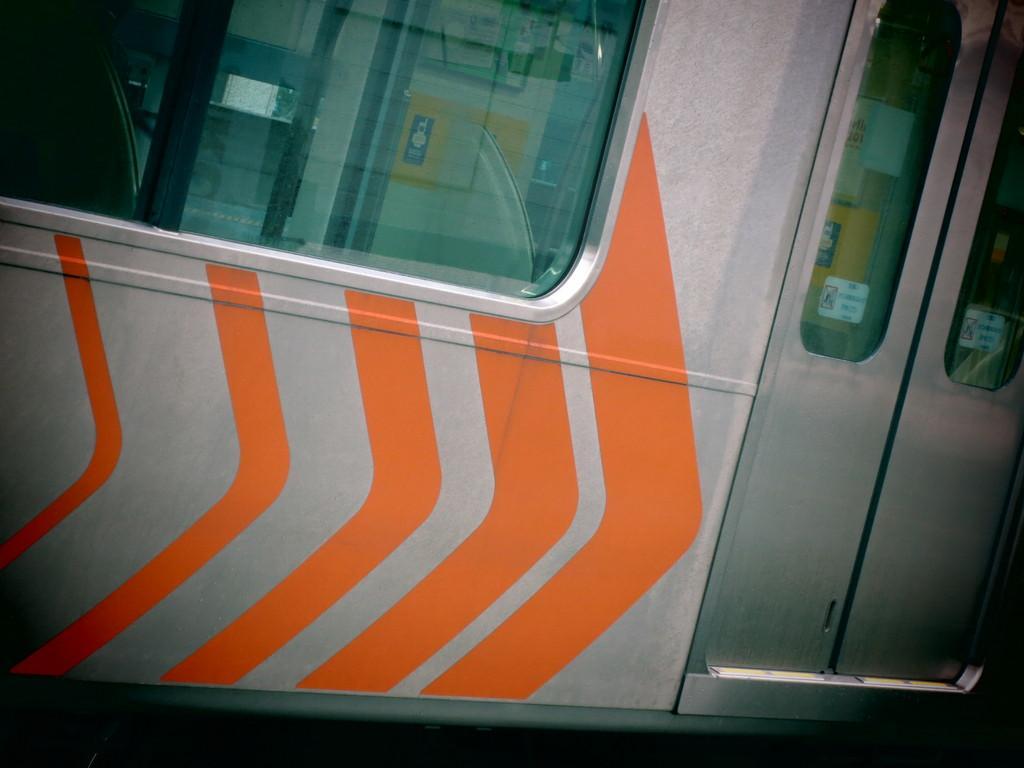How would you summarize this image in a sentence or two? In this image I can see metal doors and window seems like a metro train. 